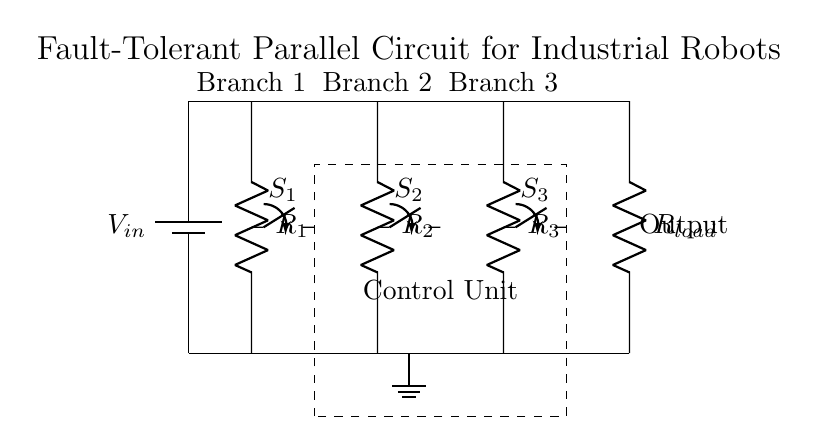What is the input voltage of this circuit? The input voltage is indicated by the battery symbol in the circuit diagram labeled as V in. This represents the power supply voltage feeding the parallel branches.
Answer: V in How many resistors are in parallel? The circuit diagram clearly shows three resistors labeled R1, R2, and R3, which are all connected in parallel between the same two voltage points.
Answer: Three What is the purpose of the control unit? The control unit is represented by the dashed rectangle in the circuit. Its purpose is to manage the states of the switches connected to each branch, allowing for fault detection and isolation of faulty components.
Answer: Manage switches If one resistor fails, what happens to the total current? In a parallel circuit, if one resistor fails (opens), the total current remains unchanged since the remaining resistors still provide a path for current flow. The current through the failing resistor would be zero, but the total current continues through the other branches.
Answer: Remains unchanged What type of switches are used in this circuit? The circuit includes single pole, single throw switches (spst), as indicated by the label next to each switch in the diagram. They allow or interrupt the current path of each branch independently.
Answer: Single pole, single throw Which component is crucial for fault detection in this setup? The control unit is crucial for fault detection as it monitors the states of the switches and can activate them to isolate faulty branches based on the detected condition of the connected resistors.
Answer: Control unit 